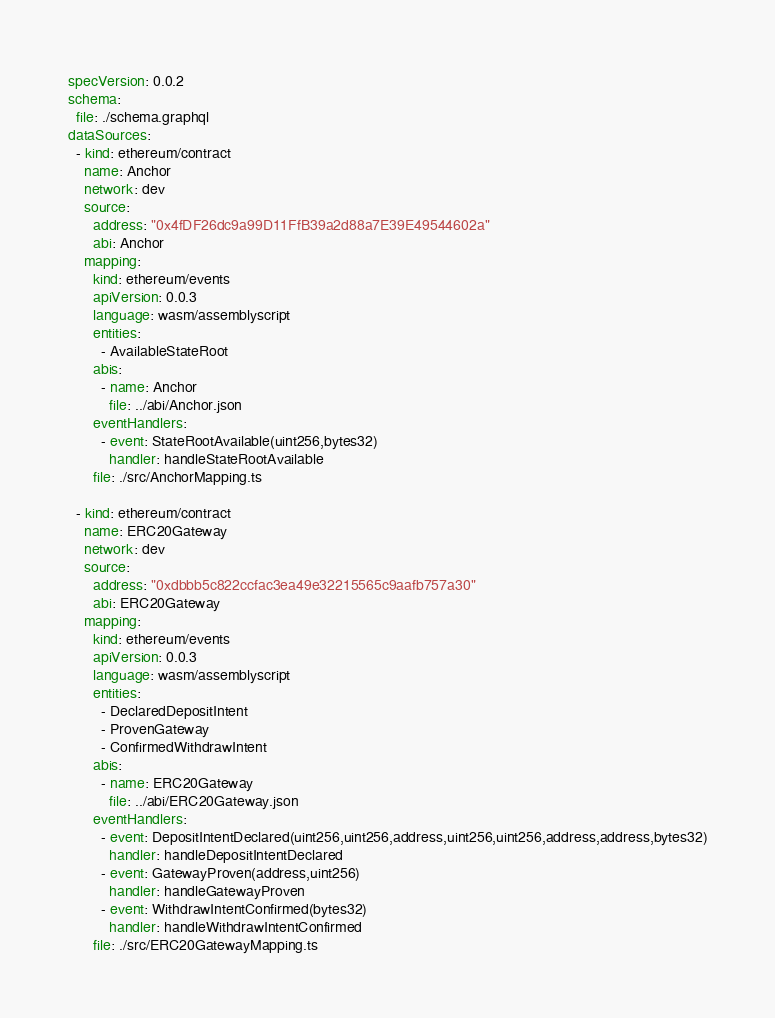Convert code to text. <code><loc_0><loc_0><loc_500><loc_500><_YAML_>specVersion: 0.0.2
schema:
  file: ./schema.graphql
dataSources:
  - kind: ethereum/contract
    name: Anchor
    network: dev
    source:
      address: "0x4fDF26dc9a99D11FfB39a2d88a7E39E49544602a"
      abi: Anchor
    mapping:
      kind: ethereum/events
      apiVersion: 0.0.3
      language: wasm/assemblyscript
      entities:
        - AvailableStateRoot
      abis:
        - name: Anchor
          file: ../abi/Anchor.json
      eventHandlers:
        - event: StateRootAvailable(uint256,bytes32)
          handler: handleStateRootAvailable
      file: ./src/AnchorMapping.ts

  - kind: ethereum/contract
    name: ERC20Gateway
    network: dev
    source:
      address: "0xdbbb5c822ccfac3ea49e32215565c9aafb757a30"
      abi: ERC20Gateway
    mapping:
      kind: ethereum/events
      apiVersion: 0.0.3
      language: wasm/assemblyscript
      entities:
        - DeclaredDepositIntent
        - ProvenGateway
        - ConfirmedWithdrawIntent
      abis:
        - name: ERC20Gateway
          file: ../abi/ERC20Gateway.json
      eventHandlers:
        - event: DepositIntentDeclared(uint256,uint256,address,uint256,uint256,address,address,bytes32)
          handler: handleDepositIntentDeclared
        - event: GatewayProven(address,uint256)
          handler: handleGatewayProven
        - event: WithdrawIntentConfirmed(bytes32)
          handler: handleWithdrawIntentConfirmed
      file: ./src/ERC20GatewayMapping.ts

</code> 